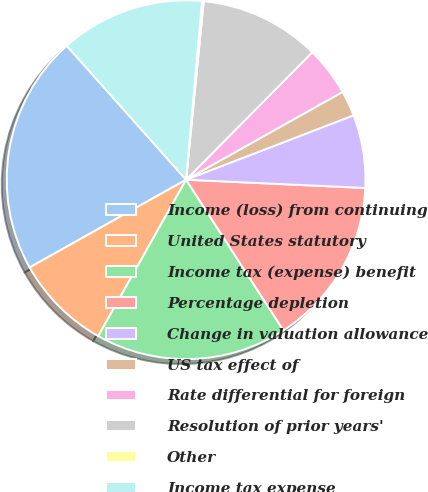<chart> <loc_0><loc_0><loc_500><loc_500><pie_chart><fcel>Income (loss) from continuing<fcel>United States statutory<fcel>Income tax (expense) benefit<fcel>Percentage depletion<fcel>Change in valuation allowance<fcel>US tax effect of<fcel>Rate differential for foreign<fcel>Resolution of prior years'<fcel>Other<fcel>Income tax expense<nl><fcel>21.56%<fcel>8.72%<fcel>17.28%<fcel>15.14%<fcel>6.58%<fcel>2.3%<fcel>4.44%<fcel>10.86%<fcel>0.15%<fcel>13.0%<nl></chart> 